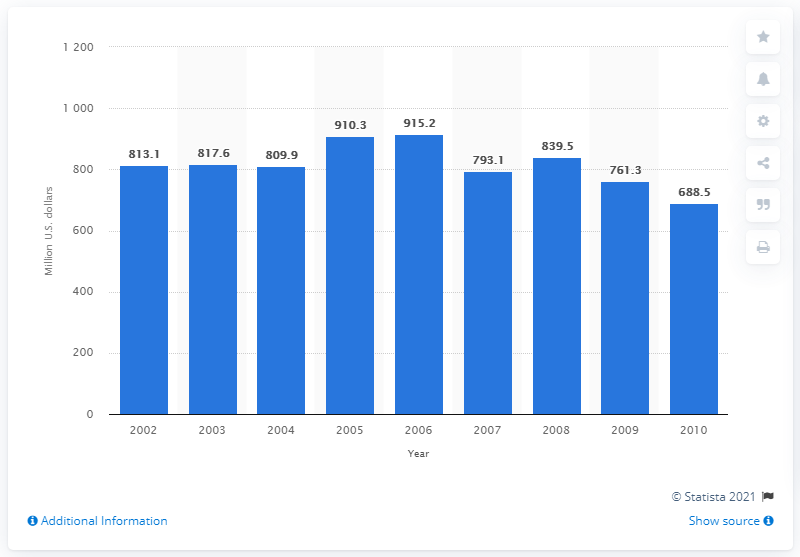Identify some key points in this picture. In 2009, the value of U.S. product shipments of school furniture was 761.3 million dollars. 